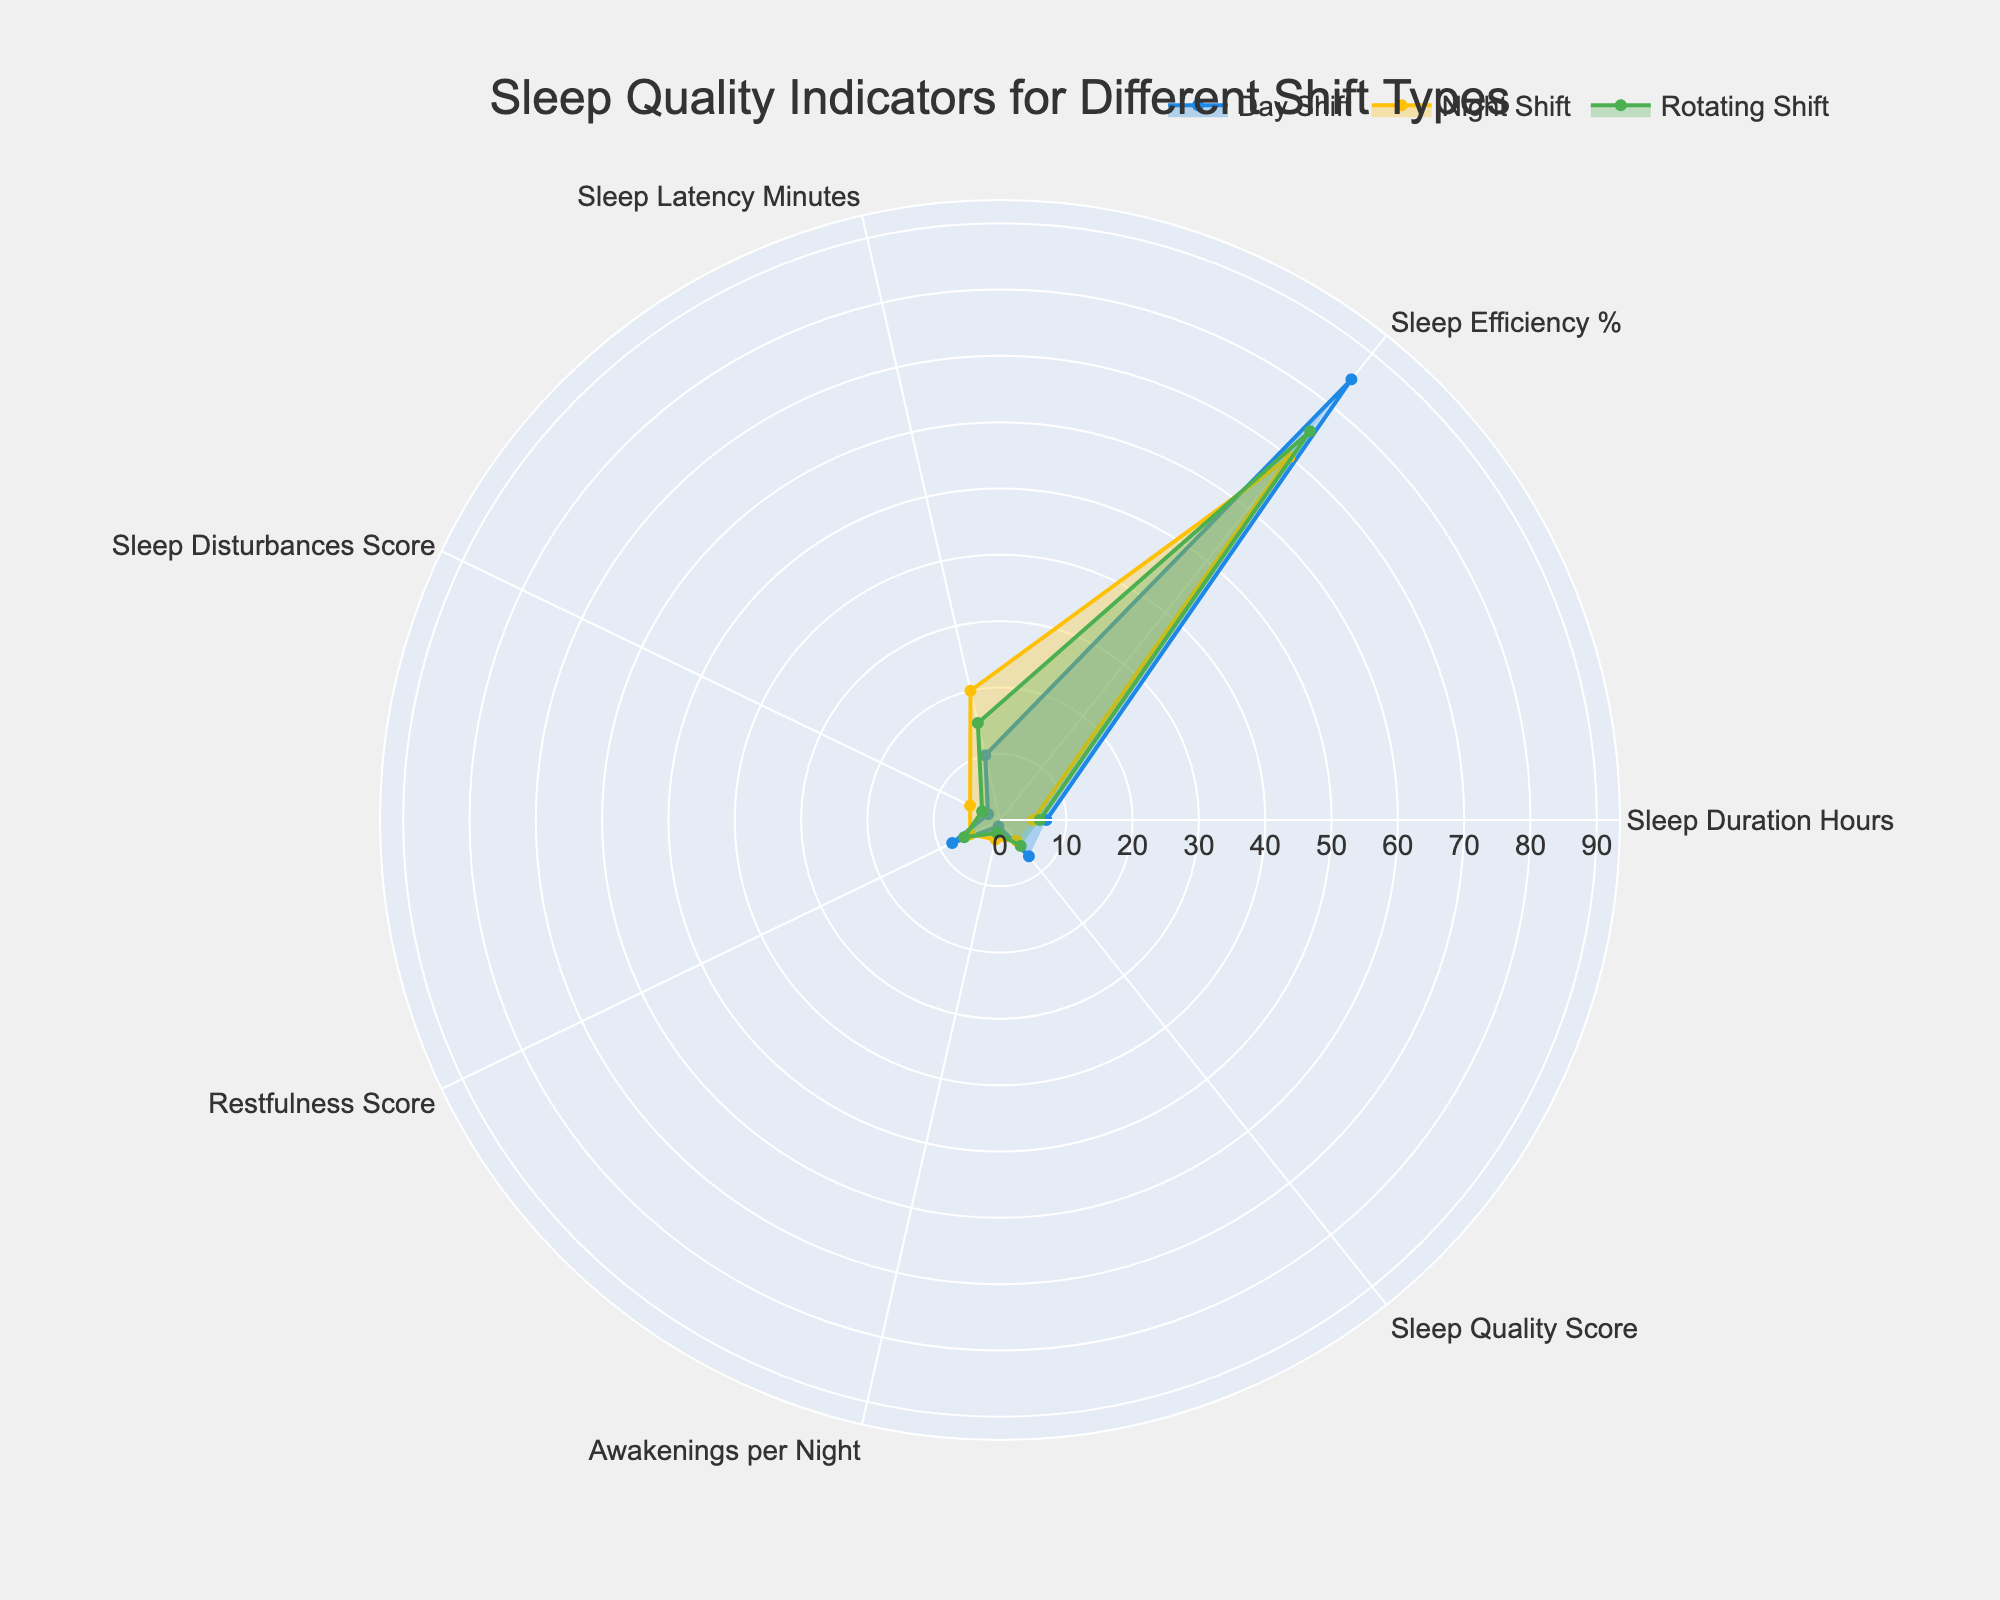What's the title of the figure? The title is usually displayed at the top center of the figure, indicating the main subject being visualized.
Answer: Sleep Quality Indicators for Different Shift Types What are the three groups compared in the radar chart? The groups are specified in the legend at the bottom of the chart. They are the different shift types being compared.
Answer: Day Shift, Night Shift, Rotating Shift Which shift has the lowest sleep efficiency percentage? Identify the sleep efficiency percentages on the radar chart and compare the values for each shift type. Night Shift shows the lowest percentage among the three groups.
Answer: Night Shift What is the difference in sleep duration hours between Day Shift and Night Shift? Locate the sleep duration hours for both Day Shift and Night Shift on the radar chart. Subtract the Night Shift value from the Day Shift value (7 - 5).
Answer: 2 Hours How does the number of awakenings per night compare between Rotating Shift and Day Shift? Observe the values for awakenings per night for both Rotating Shift and Day Shift on the radar chart. Rotating Shift has 2, while Day Shift has 1.
Answer: Rotating Shift has 1 more awakening per night than Day Shift Which sleep quality indicator shows the greatest variation across the three shifts? Identify the indicators and observe the extent of variation in values across the three shifts. The Sleep Efficiency percentage varies the most, with values of 85%, 70%, and 75%.
Answer: Sleep Efficiency % Which shift has the best (lowest) sleep latency minutes? Look for the sleep latency indicators and compare the values across all shifts. Day Shift has the lowest sleep latency of 10 minutes.
Answer: Day Shift What is the overall trend in restfulness scores among the three shifts? Examine the restfulness scores across the three shifts: Day Shift has 8, Night Shift has 5, and Rotating Shift has 6, showing a decline from Day Shift to Night Shift.
Answer: The trend decreases from Day Shift to Night Shift Calculate the average sleep quality score for all three shifts. Add the sleep quality scores for Day Shift, Night Shift, and Rotating Shift, then divide by three to find the average ((7 + 4 + 5) / 3).
Answer: 5.33 Which indicator reflects the largest difference between Day Shift and Night Shift? Compare the values for each indicator between Day Shift and Night Shift and find the largest absolute difference. Sleep Efficiency % shows the largest difference (15%).
Answer: Sleep Efficiency % 